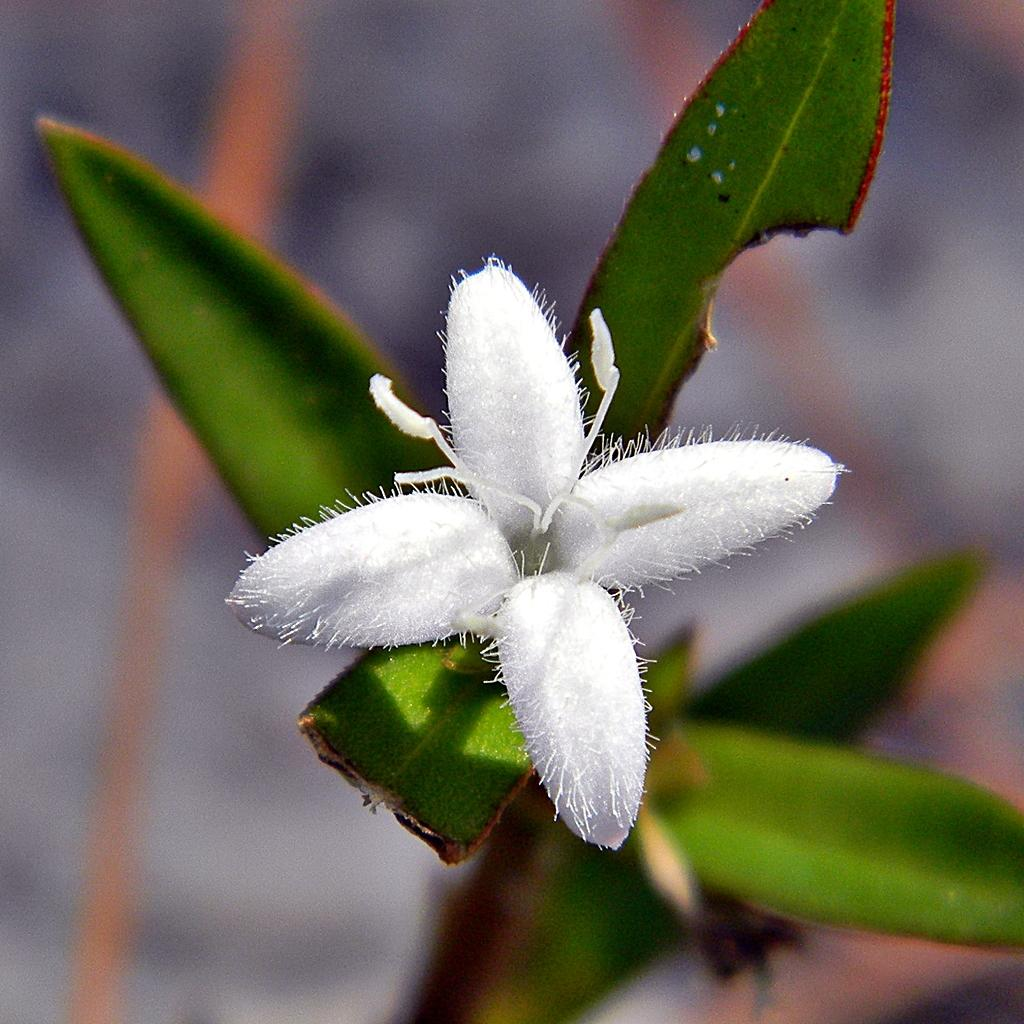What is the main subject of the image? There is a flower plant in the image. Can you describe the background of the image? The background of the image is blurred. What type of book is being written with ink in the image? There is no book or ink present in the image; it features a flower plant with a blurred background. 